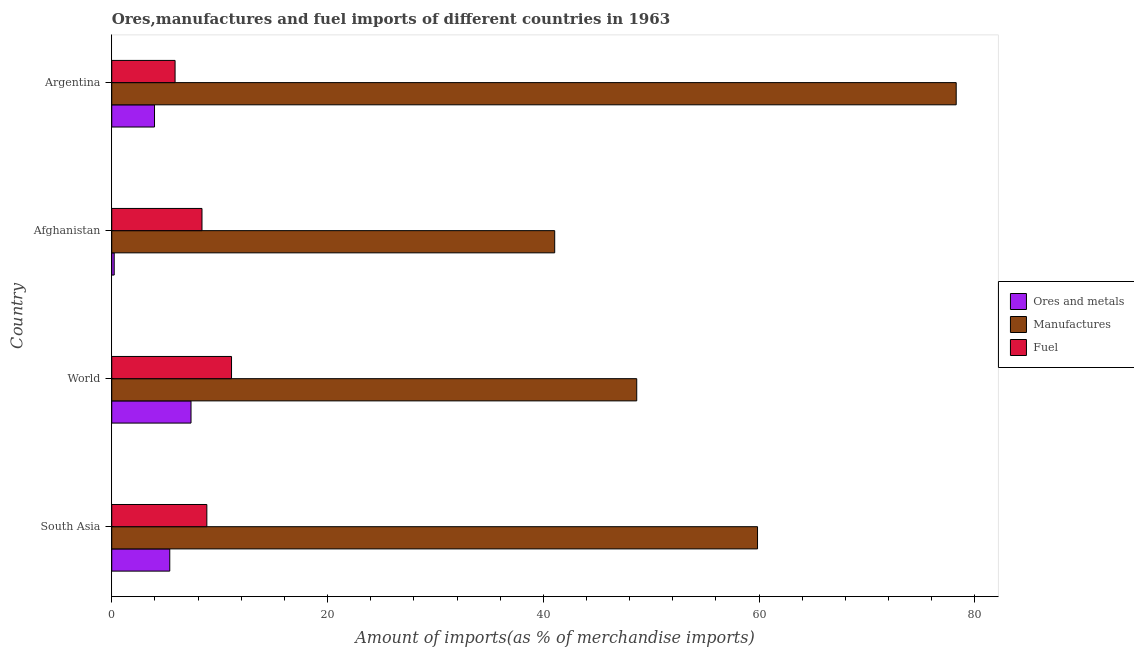How many different coloured bars are there?
Offer a very short reply. 3. Are the number of bars on each tick of the Y-axis equal?
Keep it short and to the point. Yes. In how many cases, is the number of bars for a given country not equal to the number of legend labels?
Your response must be concise. 0. What is the percentage of fuel imports in World?
Provide a short and direct response. 11.1. Across all countries, what is the maximum percentage of fuel imports?
Make the answer very short. 11.1. Across all countries, what is the minimum percentage of fuel imports?
Make the answer very short. 5.87. In which country was the percentage of manufactures imports minimum?
Provide a succinct answer. Afghanistan. What is the total percentage of manufactures imports in the graph?
Offer a very short reply. 227.84. What is the difference between the percentage of manufactures imports in South Asia and that in World?
Your answer should be compact. 11.2. What is the difference between the percentage of manufactures imports in Argentina and the percentage of ores and metals imports in Afghanistan?
Provide a succinct answer. 78.04. What is the average percentage of manufactures imports per country?
Offer a very short reply. 56.96. What is the difference between the percentage of ores and metals imports and percentage of manufactures imports in Afghanistan?
Provide a succinct answer. -40.83. What is the ratio of the percentage of manufactures imports in Argentina to that in World?
Ensure brevity in your answer.  1.61. Is the percentage of ores and metals imports in Afghanistan less than that in South Asia?
Your answer should be compact. Yes. What is the difference between the highest and the second highest percentage of ores and metals imports?
Provide a succinct answer. 1.97. What is the difference between the highest and the lowest percentage of manufactures imports?
Your answer should be compact. 37.21. Is the sum of the percentage of ores and metals imports in Afghanistan and South Asia greater than the maximum percentage of manufactures imports across all countries?
Give a very brief answer. No. What does the 1st bar from the top in Argentina represents?
Ensure brevity in your answer.  Fuel. What does the 2nd bar from the bottom in Argentina represents?
Make the answer very short. Manufactures. Is it the case that in every country, the sum of the percentage of ores and metals imports and percentage of manufactures imports is greater than the percentage of fuel imports?
Offer a terse response. Yes. How many bars are there?
Keep it short and to the point. 12. Are all the bars in the graph horizontal?
Offer a terse response. Yes. How many countries are there in the graph?
Provide a short and direct response. 4. What is the difference between two consecutive major ticks on the X-axis?
Keep it short and to the point. 20. Does the graph contain grids?
Make the answer very short. No. What is the title of the graph?
Your answer should be very brief. Ores,manufactures and fuel imports of different countries in 1963. What is the label or title of the X-axis?
Your answer should be compact. Amount of imports(as % of merchandise imports). What is the label or title of the Y-axis?
Offer a very short reply. Country. What is the Amount of imports(as % of merchandise imports) in Ores and metals in South Asia?
Your answer should be compact. 5.38. What is the Amount of imports(as % of merchandise imports) in Manufactures in South Asia?
Give a very brief answer. 59.85. What is the Amount of imports(as % of merchandise imports) in Fuel in South Asia?
Offer a very short reply. 8.81. What is the Amount of imports(as % of merchandise imports) of Ores and metals in World?
Provide a succinct answer. 7.35. What is the Amount of imports(as % of merchandise imports) in Manufactures in World?
Your answer should be compact. 48.66. What is the Amount of imports(as % of merchandise imports) in Fuel in World?
Provide a short and direct response. 11.1. What is the Amount of imports(as % of merchandise imports) in Ores and metals in Afghanistan?
Your answer should be compact. 0.23. What is the Amount of imports(as % of merchandise imports) of Manufactures in Afghanistan?
Keep it short and to the point. 41.06. What is the Amount of imports(as % of merchandise imports) of Fuel in Afghanistan?
Provide a short and direct response. 8.36. What is the Amount of imports(as % of merchandise imports) of Ores and metals in Argentina?
Provide a short and direct response. 3.96. What is the Amount of imports(as % of merchandise imports) of Manufactures in Argentina?
Your answer should be very brief. 78.27. What is the Amount of imports(as % of merchandise imports) of Fuel in Argentina?
Keep it short and to the point. 5.87. Across all countries, what is the maximum Amount of imports(as % of merchandise imports) in Ores and metals?
Keep it short and to the point. 7.35. Across all countries, what is the maximum Amount of imports(as % of merchandise imports) of Manufactures?
Ensure brevity in your answer.  78.27. Across all countries, what is the maximum Amount of imports(as % of merchandise imports) of Fuel?
Provide a short and direct response. 11.1. Across all countries, what is the minimum Amount of imports(as % of merchandise imports) of Ores and metals?
Ensure brevity in your answer.  0.23. Across all countries, what is the minimum Amount of imports(as % of merchandise imports) of Manufactures?
Your answer should be compact. 41.06. Across all countries, what is the minimum Amount of imports(as % of merchandise imports) in Fuel?
Give a very brief answer. 5.87. What is the total Amount of imports(as % of merchandise imports) in Ores and metals in the graph?
Make the answer very short. 16.92. What is the total Amount of imports(as % of merchandise imports) of Manufactures in the graph?
Your answer should be compact. 227.84. What is the total Amount of imports(as % of merchandise imports) of Fuel in the graph?
Keep it short and to the point. 34.15. What is the difference between the Amount of imports(as % of merchandise imports) of Ores and metals in South Asia and that in World?
Give a very brief answer. -1.97. What is the difference between the Amount of imports(as % of merchandise imports) of Manufactures in South Asia and that in World?
Provide a short and direct response. 11.2. What is the difference between the Amount of imports(as % of merchandise imports) in Fuel in South Asia and that in World?
Make the answer very short. -2.29. What is the difference between the Amount of imports(as % of merchandise imports) of Ores and metals in South Asia and that in Afghanistan?
Offer a very short reply. 5.15. What is the difference between the Amount of imports(as % of merchandise imports) of Manufactures in South Asia and that in Afghanistan?
Provide a succinct answer. 18.8. What is the difference between the Amount of imports(as % of merchandise imports) of Fuel in South Asia and that in Afghanistan?
Your answer should be very brief. 0.45. What is the difference between the Amount of imports(as % of merchandise imports) of Ores and metals in South Asia and that in Argentina?
Keep it short and to the point. 1.41. What is the difference between the Amount of imports(as % of merchandise imports) in Manufactures in South Asia and that in Argentina?
Offer a terse response. -18.42. What is the difference between the Amount of imports(as % of merchandise imports) in Fuel in South Asia and that in Argentina?
Provide a short and direct response. 2.94. What is the difference between the Amount of imports(as % of merchandise imports) in Ores and metals in World and that in Afghanistan?
Offer a very short reply. 7.12. What is the difference between the Amount of imports(as % of merchandise imports) of Manufactures in World and that in Afghanistan?
Your answer should be very brief. 7.6. What is the difference between the Amount of imports(as % of merchandise imports) of Fuel in World and that in Afghanistan?
Give a very brief answer. 2.74. What is the difference between the Amount of imports(as % of merchandise imports) in Ores and metals in World and that in Argentina?
Your answer should be compact. 3.38. What is the difference between the Amount of imports(as % of merchandise imports) of Manufactures in World and that in Argentina?
Offer a terse response. -29.61. What is the difference between the Amount of imports(as % of merchandise imports) of Fuel in World and that in Argentina?
Give a very brief answer. 5.23. What is the difference between the Amount of imports(as % of merchandise imports) in Ores and metals in Afghanistan and that in Argentina?
Offer a terse response. -3.74. What is the difference between the Amount of imports(as % of merchandise imports) in Manufactures in Afghanistan and that in Argentina?
Make the answer very short. -37.21. What is the difference between the Amount of imports(as % of merchandise imports) of Fuel in Afghanistan and that in Argentina?
Give a very brief answer. 2.49. What is the difference between the Amount of imports(as % of merchandise imports) of Ores and metals in South Asia and the Amount of imports(as % of merchandise imports) of Manufactures in World?
Your response must be concise. -43.28. What is the difference between the Amount of imports(as % of merchandise imports) in Ores and metals in South Asia and the Amount of imports(as % of merchandise imports) in Fuel in World?
Ensure brevity in your answer.  -5.72. What is the difference between the Amount of imports(as % of merchandise imports) of Manufactures in South Asia and the Amount of imports(as % of merchandise imports) of Fuel in World?
Keep it short and to the point. 48.75. What is the difference between the Amount of imports(as % of merchandise imports) of Ores and metals in South Asia and the Amount of imports(as % of merchandise imports) of Manufactures in Afghanistan?
Ensure brevity in your answer.  -35.68. What is the difference between the Amount of imports(as % of merchandise imports) in Ores and metals in South Asia and the Amount of imports(as % of merchandise imports) in Fuel in Afghanistan?
Keep it short and to the point. -2.99. What is the difference between the Amount of imports(as % of merchandise imports) in Manufactures in South Asia and the Amount of imports(as % of merchandise imports) in Fuel in Afghanistan?
Your answer should be compact. 51.49. What is the difference between the Amount of imports(as % of merchandise imports) of Ores and metals in South Asia and the Amount of imports(as % of merchandise imports) of Manufactures in Argentina?
Your answer should be compact. -72.89. What is the difference between the Amount of imports(as % of merchandise imports) in Ores and metals in South Asia and the Amount of imports(as % of merchandise imports) in Fuel in Argentina?
Provide a succinct answer. -0.49. What is the difference between the Amount of imports(as % of merchandise imports) of Manufactures in South Asia and the Amount of imports(as % of merchandise imports) of Fuel in Argentina?
Ensure brevity in your answer.  53.99. What is the difference between the Amount of imports(as % of merchandise imports) in Ores and metals in World and the Amount of imports(as % of merchandise imports) in Manufactures in Afghanistan?
Ensure brevity in your answer.  -33.71. What is the difference between the Amount of imports(as % of merchandise imports) of Ores and metals in World and the Amount of imports(as % of merchandise imports) of Fuel in Afghanistan?
Ensure brevity in your answer.  -1.02. What is the difference between the Amount of imports(as % of merchandise imports) in Manufactures in World and the Amount of imports(as % of merchandise imports) in Fuel in Afghanistan?
Provide a succinct answer. 40.3. What is the difference between the Amount of imports(as % of merchandise imports) in Ores and metals in World and the Amount of imports(as % of merchandise imports) in Manufactures in Argentina?
Keep it short and to the point. -70.92. What is the difference between the Amount of imports(as % of merchandise imports) of Ores and metals in World and the Amount of imports(as % of merchandise imports) of Fuel in Argentina?
Keep it short and to the point. 1.48. What is the difference between the Amount of imports(as % of merchandise imports) in Manufactures in World and the Amount of imports(as % of merchandise imports) in Fuel in Argentina?
Your answer should be very brief. 42.79. What is the difference between the Amount of imports(as % of merchandise imports) of Ores and metals in Afghanistan and the Amount of imports(as % of merchandise imports) of Manufactures in Argentina?
Your answer should be very brief. -78.04. What is the difference between the Amount of imports(as % of merchandise imports) in Ores and metals in Afghanistan and the Amount of imports(as % of merchandise imports) in Fuel in Argentina?
Offer a terse response. -5.64. What is the difference between the Amount of imports(as % of merchandise imports) in Manufactures in Afghanistan and the Amount of imports(as % of merchandise imports) in Fuel in Argentina?
Your answer should be compact. 35.19. What is the average Amount of imports(as % of merchandise imports) of Ores and metals per country?
Ensure brevity in your answer.  4.23. What is the average Amount of imports(as % of merchandise imports) in Manufactures per country?
Offer a very short reply. 56.96. What is the average Amount of imports(as % of merchandise imports) of Fuel per country?
Make the answer very short. 8.54. What is the difference between the Amount of imports(as % of merchandise imports) of Ores and metals and Amount of imports(as % of merchandise imports) of Manufactures in South Asia?
Your answer should be compact. -54.48. What is the difference between the Amount of imports(as % of merchandise imports) of Ores and metals and Amount of imports(as % of merchandise imports) of Fuel in South Asia?
Offer a terse response. -3.44. What is the difference between the Amount of imports(as % of merchandise imports) in Manufactures and Amount of imports(as % of merchandise imports) in Fuel in South Asia?
Your response must be concise. 51.04. What is the difference between the Amount of imports(as % of merchandise imports) of Ores and metals and Amount of imports(as % of merchandise imports) of Manufactures in World?
Offer a terse response. -41.31. What is the difference between the Amount of imports(as % of merchandise imports) in Ores and metals and Amount of imports(as % of merchandise imports) in Fuel in World?
Your response must be concise. -3.75. What is the difference between the Amount of imports(as % of merchandise imports) of Manufactures and Amount of imports(as % of merchandise imports) of Fuel in World?
Your answer should be very brief. 37.56. What is the difference between the Amount of imports(as % of merchandise imports) in Ores and metals and Amount of imports(as % of merchandise imports) in Manufactures in Afghanistan?
Keep it short and to the point. -40.83. What is the difference between the Amount of imports(as % of merchandise imports) of Ores and metals and Amount of imports(as % of merchandise imports) of Fuel in Afghanistan?
Your response must be concise. -8.14. What is the difference between the Amount of imports(as % of merchandise imports) in Manufactures and Amount of imports(as % of merchandise imports) in Fuel in Afghanistan?
Keep it short and to the point. 32.69. What is the difference between the Amount of imports(as % of merchandise imports) in Ores and metals and Amount of imports(as % of merchandise imports) in Manufactures in Argentina?
Provide a short and direct response. -74.31. What is the difference between the Amount of imports(as % of merchandise imports) in Ores and metals and Amount of imports(as % of merchandise imports) in Fuel in Argentina?
Provide a short and direct response. -1.91. What is the difference between the Amount of imports(as % of merchandise imports) of Manufactures and Amount of imports(as % of merchandise imports) of Fuel in Argentina?
Make the answer very short. 72.4. What is the ratio of the Amount of imports(as % of merchandise imports) of Ores and metals in South Asia to that in World?
Give a very brief answer. 0.73. What is the ratio of the Amount of imports(as % of merchandise imports) of Manufactures in South Asia to that in World?
Provide a short and direct response. 1.23. What is the ratio of the Amount of imports(as % of merchandise imports) of Fuel in South Asia to that in World?
Provide a short and direct response. 0.79. What is the ratio of the Amount of imports(as % of merchandise imports) of Ores and metals in South Asia to that in Afghanistan?
Make the answer very short. 23.6. What is the ratio of the Amount of imports(as % of merchandise imports) of Manufactures in South Asia to that in Afghanistan?
Your answer should be compact. 1.46. What is the ratio of the Amount of imports(as % of merchandise imports) of Fuel in South Asia to that in Afghanistan?
Make the answer very short. 1.05. What is the ratio of the Amount of imports(as % of merchandise imports) of Ores and metals in South Asia to that in Argentina?
Ensure brevity in your answer.  1.36. What is the ratio of the Amount of imports(as % of merchandise imports) of Manufactures in South Asia to that in Argentina?
Provide a short and direct response. 0.76. What is the ratio of the Amount of imports(as % of merchandise imports) in Fuel in South Asia to that in Argentina?
Your answer should be very brief. 1.5. What is the ratio of the Amount of imports(as % of merchandise imports) of Ores and metals in World to that in Afghanistan?
Provide a succinct answer. 32.24. What is the ratio of the Amount of imports(as % of merchandise imports) of Manufactures in World to that in Afghanistan?
Your answer should be compact. 1.19. What is the ratio of the Amount of imports(as % of merchandise imports) in Fuel in World to that in Afghanistan?
Offer a terse response. 1.33. What is the ratio of the Amount of imports(as % of merchandise imports) in Ores and metals in World to that in Argentina?
Ensure brevity in your answer.  1.85. What is the ratio of the Amount of imports(as % of merchandise imports) in Manufactures in World to that in Argentina?
Your answer should be compact. 0.62. What is the ratio of the Amount of imports(as % of merchandise imports) of Fuel in World to that in Argentina?
Your answer should be very brief. 1.89. What is the ratio of the Amount of imports(as % of merchandise imports) in Ores and metals in Afghanistan to that in Argentina?
Provide a succinct answer. 0.06. What is the ratio of the Amount of imports(as % of merchandise imports) in Manufactures in Afghanistan to that in Argentina?
Ensure brevity in your answer.  0.52. What is the ratio of the Amount of imports(as % of merchandise imports) of Fuel in Afghanistan to that in Argentina?
Your answer should be very brief. 1.42. What is the difference between the highest and the second highest Amount of imports(as % of merchandise imports) in Ores and metals?
Offer a terse response. 1.97. What is the difference between the highest and the second highest Amount of imports(as % of merchandise imports) of Manufactures?
Provide a short and direct response. 18.42. What is the difference between the highest and the second highest Amount of imports(as % of merchandise imports) in Fuel?
Offer a terse response. 2.29. What is the difference between the highest and the lowest Amount of imports(as % of merchandise imports) of Ores and metals?
Your answer should be compact. 7.12. What is the difference between the highest and the lowest Amount of imports(as % of merchandise imports) of Manufactures?
Make the answer very short. 37.21. What is the difference between the highest and the lowest Amount of imports(as % of merchandise imports) of Fuel?
Keep it short and to the point. 5.23. 